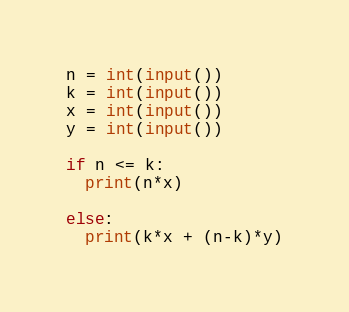<code> <loc_0><loc_0><loc_500><loc_500><_Python_>n = int(input())
k = int(input())
x = int(input())
y = int(input())

if n <= k:
  print(n*x)
  
else:
  print(k*x + (n-k)*y)</code> 